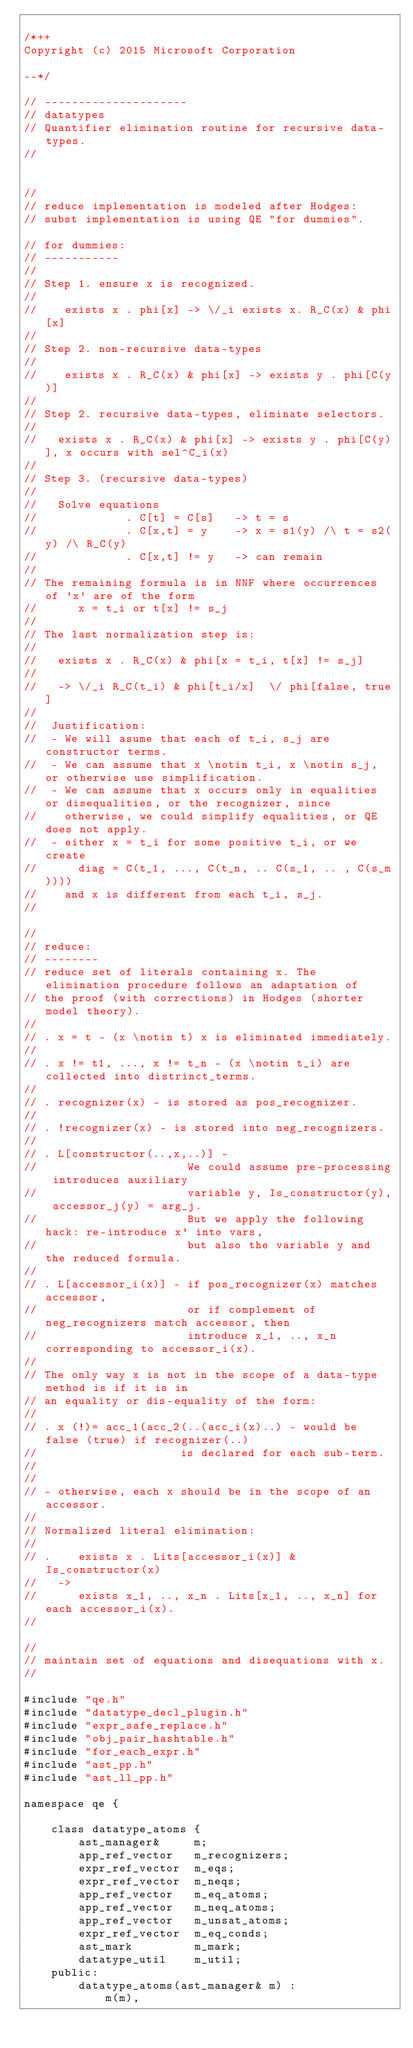<code> <loc_0><loc_0><loc_500><loc_500><_C++_>
/*++
Copyright (c) 2015 Microsoft Corporation

--*/

// ---------------------
// datatypes
// Quantifier elimination routine for recursive data-types.
// 


//
// reduce implementation is modeled after Hodges:
// subst implementation is using QE "for dummies".

// for dummies:
// -----------
// 
// Step 1. ensure x is recognized.
// 
//    exists x . phi[x] -> \/_i exists x. R_C(x) & phi[x]    
// 
// Step 2. non-recursive data-types
// 
//    exists x . R_C(x) & phi[x] -> exists y . phi[C(y)]
// 
// Step 2. recursive data-types, eliminate selectors.
// 
//   exists x . R_C(x) & phi[x] -> exists y . phi[C(y)], x occurs with sel^C_i(x)
//
// Step 3. (recursive data-types)
//   
//   Solve equations 
//             . C[t] = C[s]   -> t = s
//             . C[x,t] = y    -> x = s1(y) /\ t = s2(y) /\ R_C(y) 
//             . C[x,t] != y   -> can remain 
// 
// The remaining formula is in NNF where occurrences of 'x' are of the form
//      x = t_i or t[x] != s_j
// 
// The last normalization step is:
// 
//   exists x . R_C(x) & phi[x = t_i, t[x] != s_j]
// 
//   -> \/_i R_C(t_i) & phi[t_i/x]  \/ phi[false, true]
// 
//  Justification: 
//  - We will asume that each of t_i, s_j are constructor terms.
//  - We can assume that x \notin t_i, x \notin s_j, or otherwise use simplification.
//  - We can assume that x occurs only in equalities or disequalities, or the recognizer, since 
//    otherwise, we could simplify equalities, or QE does not apply.
//  - either x = t_i for some positive t_i, or we create 
//      diag = C(t_1, ..., C(t_n, .. C(s_1, .. , C(s_m))))
//    and x is different from each t_i, s_j.
//    

//
// reduce:
// --------
// reduce set of literals containing x. The elimination procedure follows an adaptation of 
// the proof (with corrections) in Hodges (shorter model theory).
//
// . x = t - (x \notin t) x is eliminated immediately.
// 
// . x != t1, ..., x != t_n - (x \notin t_i) are collected into distrinct_terms.
// 
// . recognizer(x) - is stored as pos_recognizer.
// 
// . !recognizer(x) - is stored into neg_recognizers.
//
// . L[constructor(..,x,..)] - 
//                      We could assume pre-processing introduces auxiliary 
//                      variable y, Is_constructor(y), accessor_j(y) = arg_j.
//                      But we apply the following hack: re-introduce x' into vars, 
//                      but also the variable y and the reduced formula.
// 
// . L[accessor_i(x)] - if pos_recognizer(x) matches accessor, 
//                      or if complement of neg_recognizers match accessor, then 
//                      introduce x_1, .., x_n corresponding to accessor_i(x).
//                      
// The only way x is not in the scope of a data-type method is if it is in 
// an equality or dis-equality of the form:
// 
// . x (!)= acc_1(acc_2(..(acc_i(x)..) - would be false (true) if recognizer(..) 
//                     is declared for each sub-term.
// 
// 
// - otherwise, each x should be in the scope of an accessor.
// 
// Normalized literal elimination:
// 
// .    exists x . Lits[accessor_i(x)] & Is_constructor(x) 
//   -> 
//      exists x_1, .., x_n . Lits[x_1, .., x_n] for each accessor_i(x).
// 

//
// maintain set of equations and disequations with x.
//

#include "qe.h"
#include "datatype_decl_plugin.h"
#include "expr_safe_replace.h"
#include "obj_pair_hashtable.h"
#include "for_each_expr.h"
#include "ast_pp.h"
#include "ast_ll_pp.h"

namespace qe {

    class datatype_atoms {
        ast_manager&     m;
        app_ref_vector   m_recognizers;
        expr_ref_vector  m_eqs;
        expr_ref_vector  m_neqs;
        app_ref_vector   m_eq_atoms;
        app_ref_vector   m_neq_atoms;
        app_ref_vector   m_unsat_atoms;
        expr_ref_vector  m_eq_conds;
        ast_mark         m_mark;
        datatype_util    m_util;
    public:
        datatype_atoms(ast_manager& m) :
            m(m), </code> 